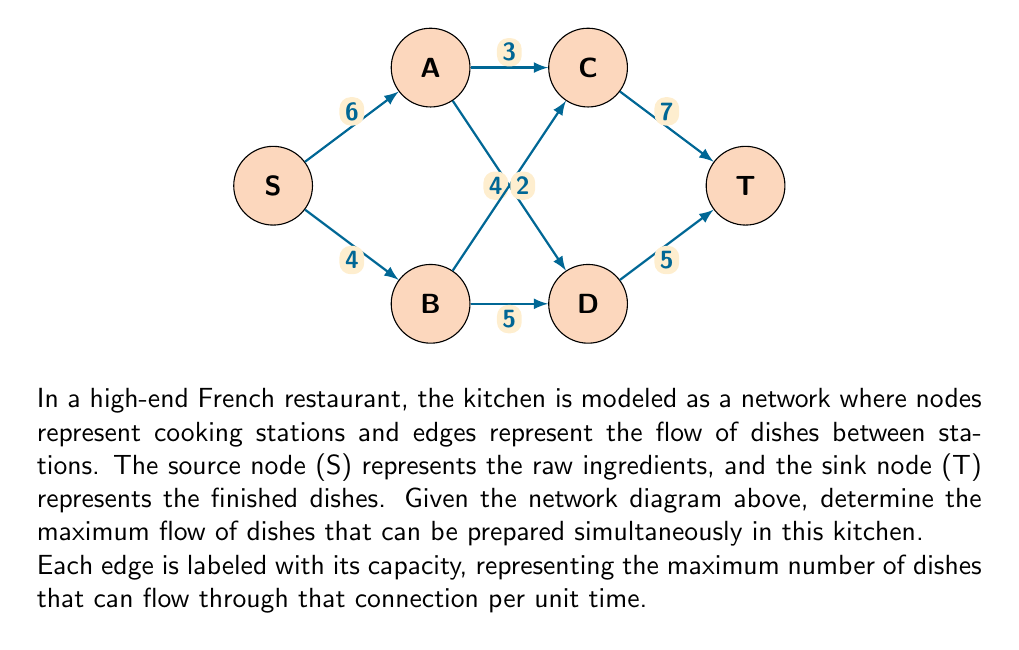Can you answer this question? To find the maximum flow in this network, we'll use the Ford-Fulkerson algorithm:

1) Initialize flow to 0 for all edges.

2) Find an augmenting path from S to T:
   Path 1: S -> A -> C -> T (min capacity: 3)
   Increase flow by 3 along this path.

3) Update residual graph and find another path:
   Path 2: S -> B -> D -> T (min capacity: 4)
   Increase flow by 4 along this path.

4) Update residual graph and find another path:
   Path 3: S -> A -> D -> T (min capacity: 1)
   Increase flow by 1 along this path.

5) Update residual graph and find another path:
   Path 4: S -> B -> C -> T (min capacity: 2)
   Increase flow by 2 along this path.

6) No more augmenting paths exist.

7) Calculate total flow:
   $\text{Total Flow} = 3 + 4 + 1 + 2 = 10$

Therefore, the maximum flow of dishes that can be prepared simultaneously is 10.

This can be verified by examining the cut (S, {A,B,C,D,T}), which has a capacity of 10 (6+4 from S to A and B).
Answer: 10 dishes 